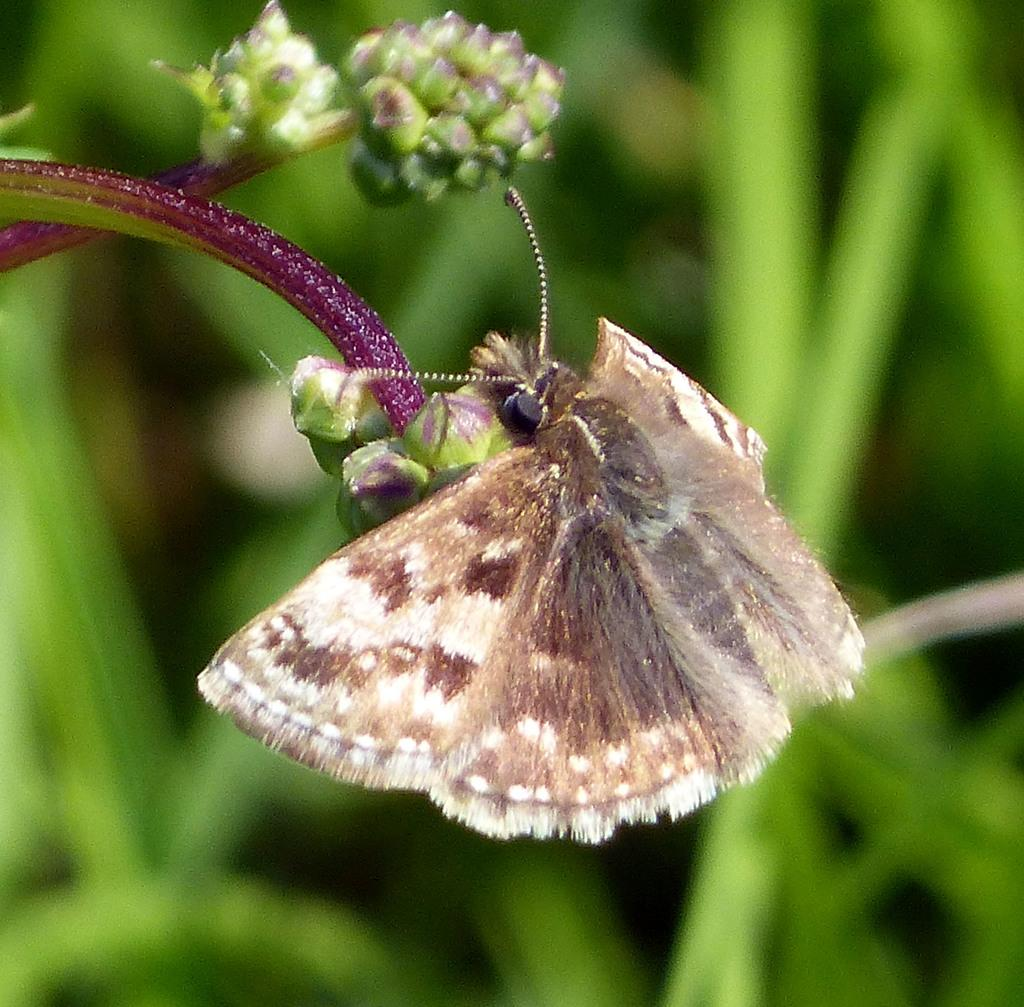What is the main subject of the image? There is a butterfly in the image. What is the butterfly doing in the image? The butterfly is eating flowers. What can be seen in the background of the image? There are green leaves in the background of the image. What type of machine can be seen in the background of the image? There is no machine present in the image; it features a butterfly eating flowers with green leaves in the background. 